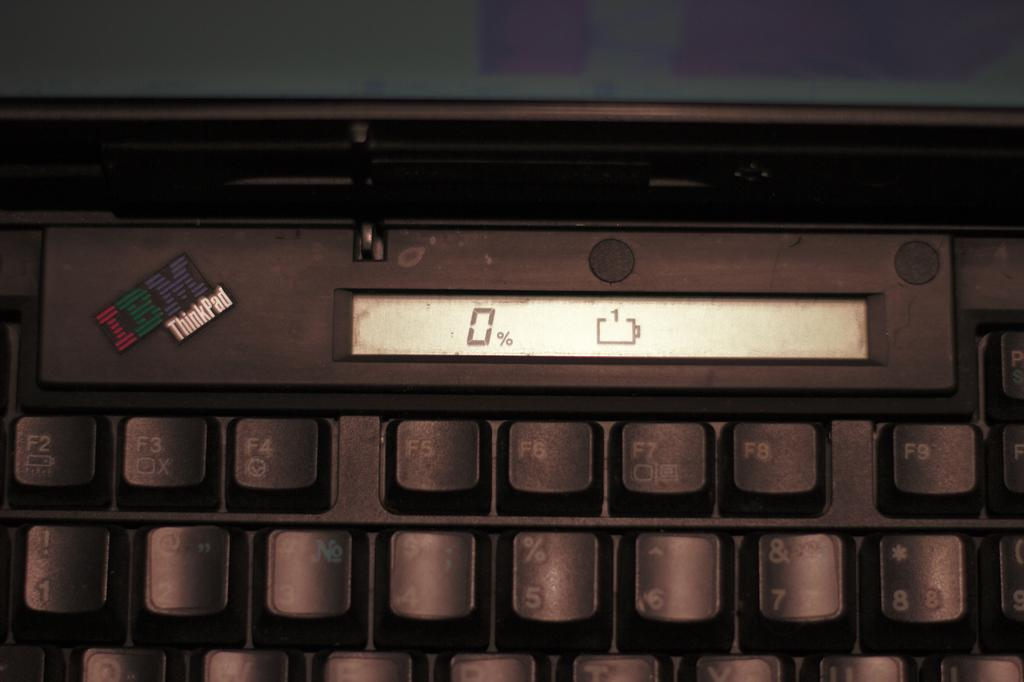<image>
Write a terse but informative summary of the picture. IBM Thinkpad keyboard that shows 0% and no battery. 